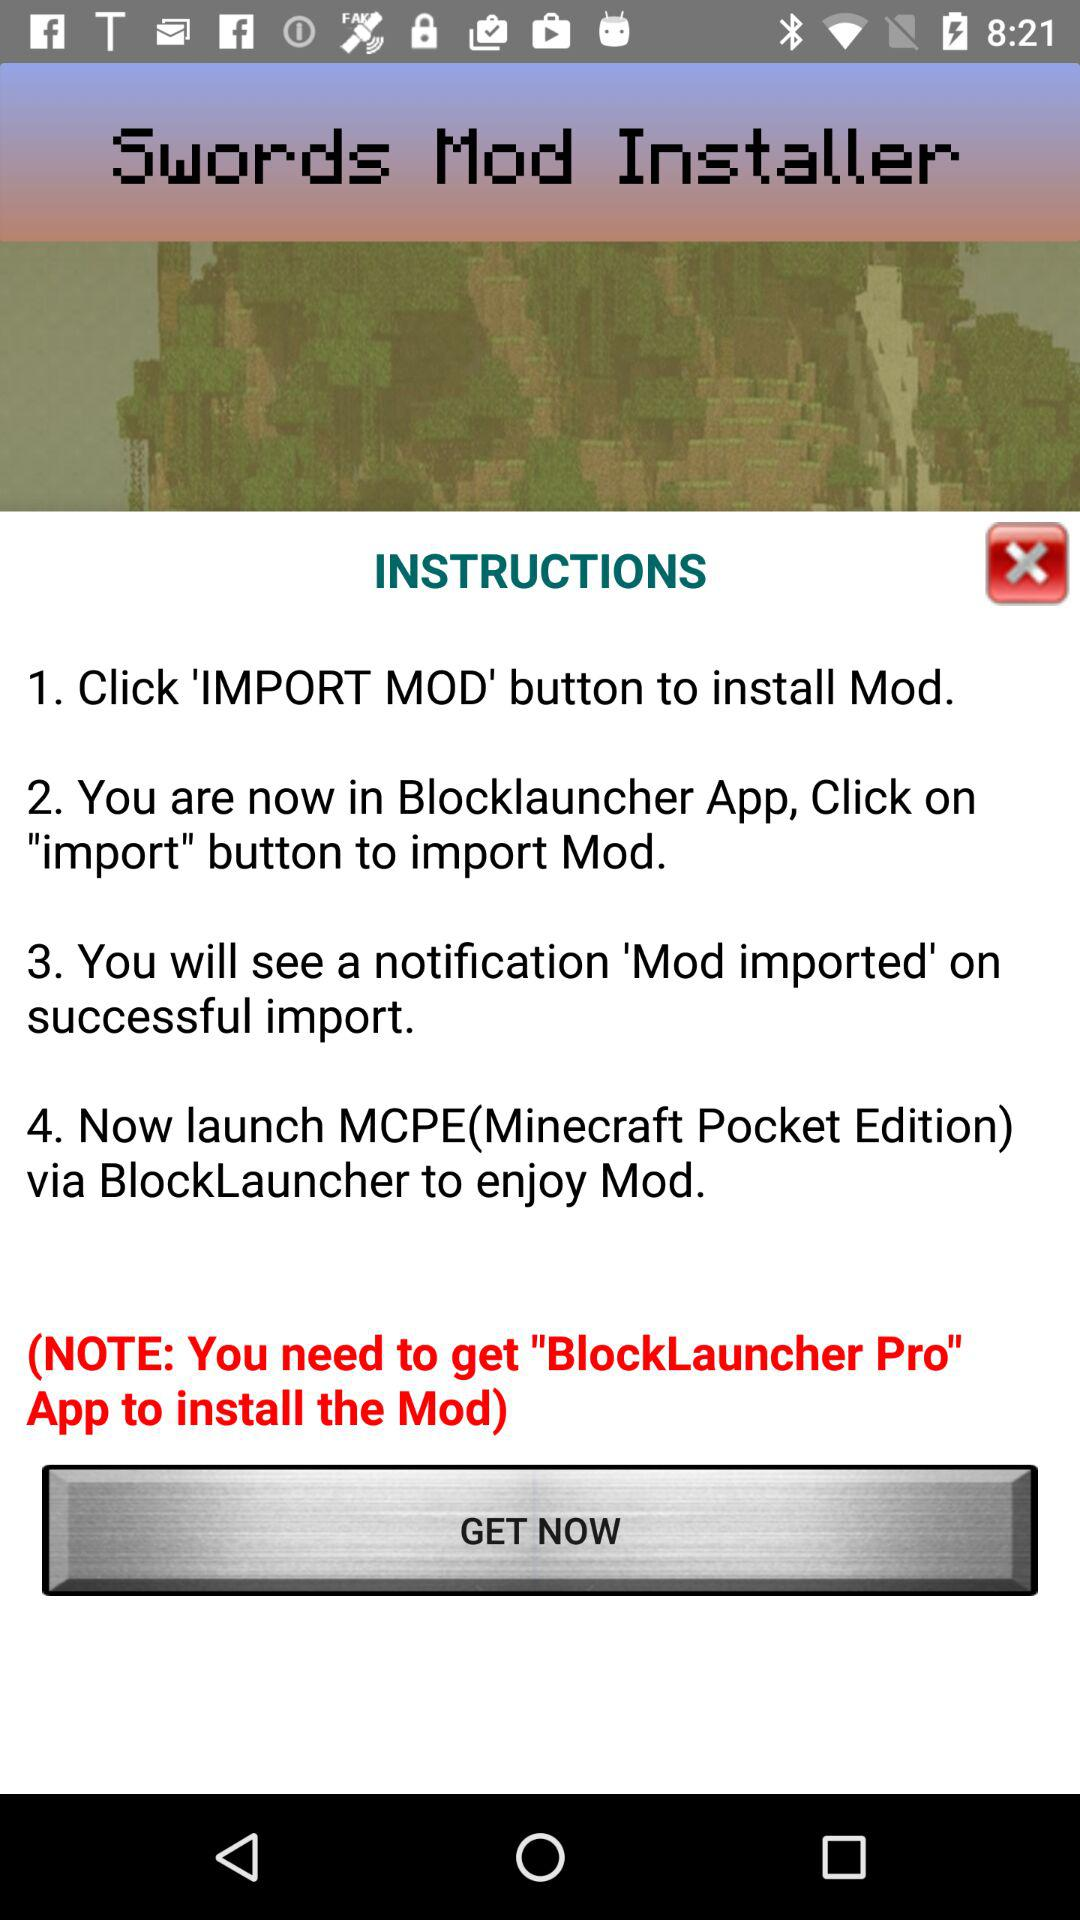How many steps are there in the instructions?
Answer the question using a single word or phrase. 4 